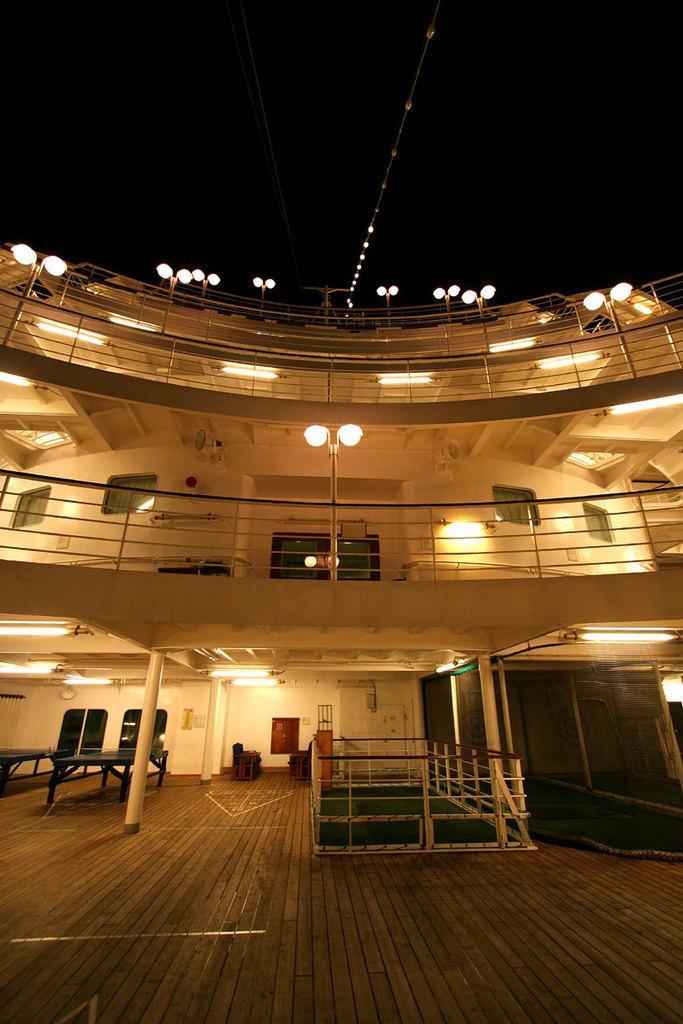In one or two sentences, can you explain what this image depicts? In the picture we can see a building with three floors, on the ground floor we can see some pillars, tables, chairs, lights and on the first floor, we can see a railing and a pole with lights and on the third floor we can see railings and lights. 